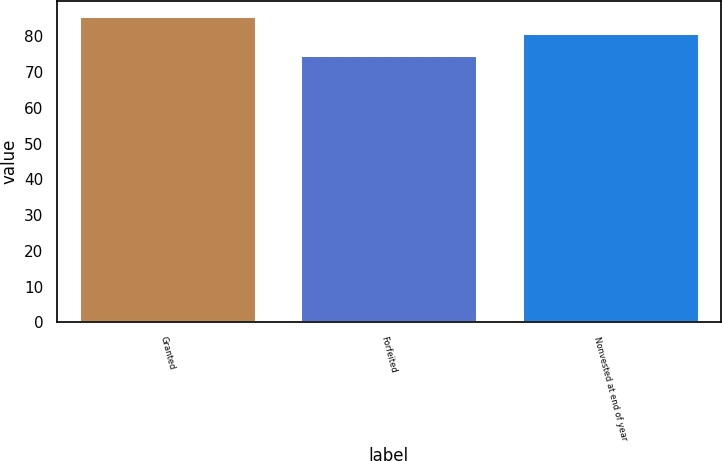<chart> <loc_0><loc_0><loc_500><loc_500><bar_chart><fcel>Granted<fcel>Forfeited<fcel>Nonvested at end of year<nl><fcel>85.62<fcel>74.87<fcel>80.91<nl></chart> 